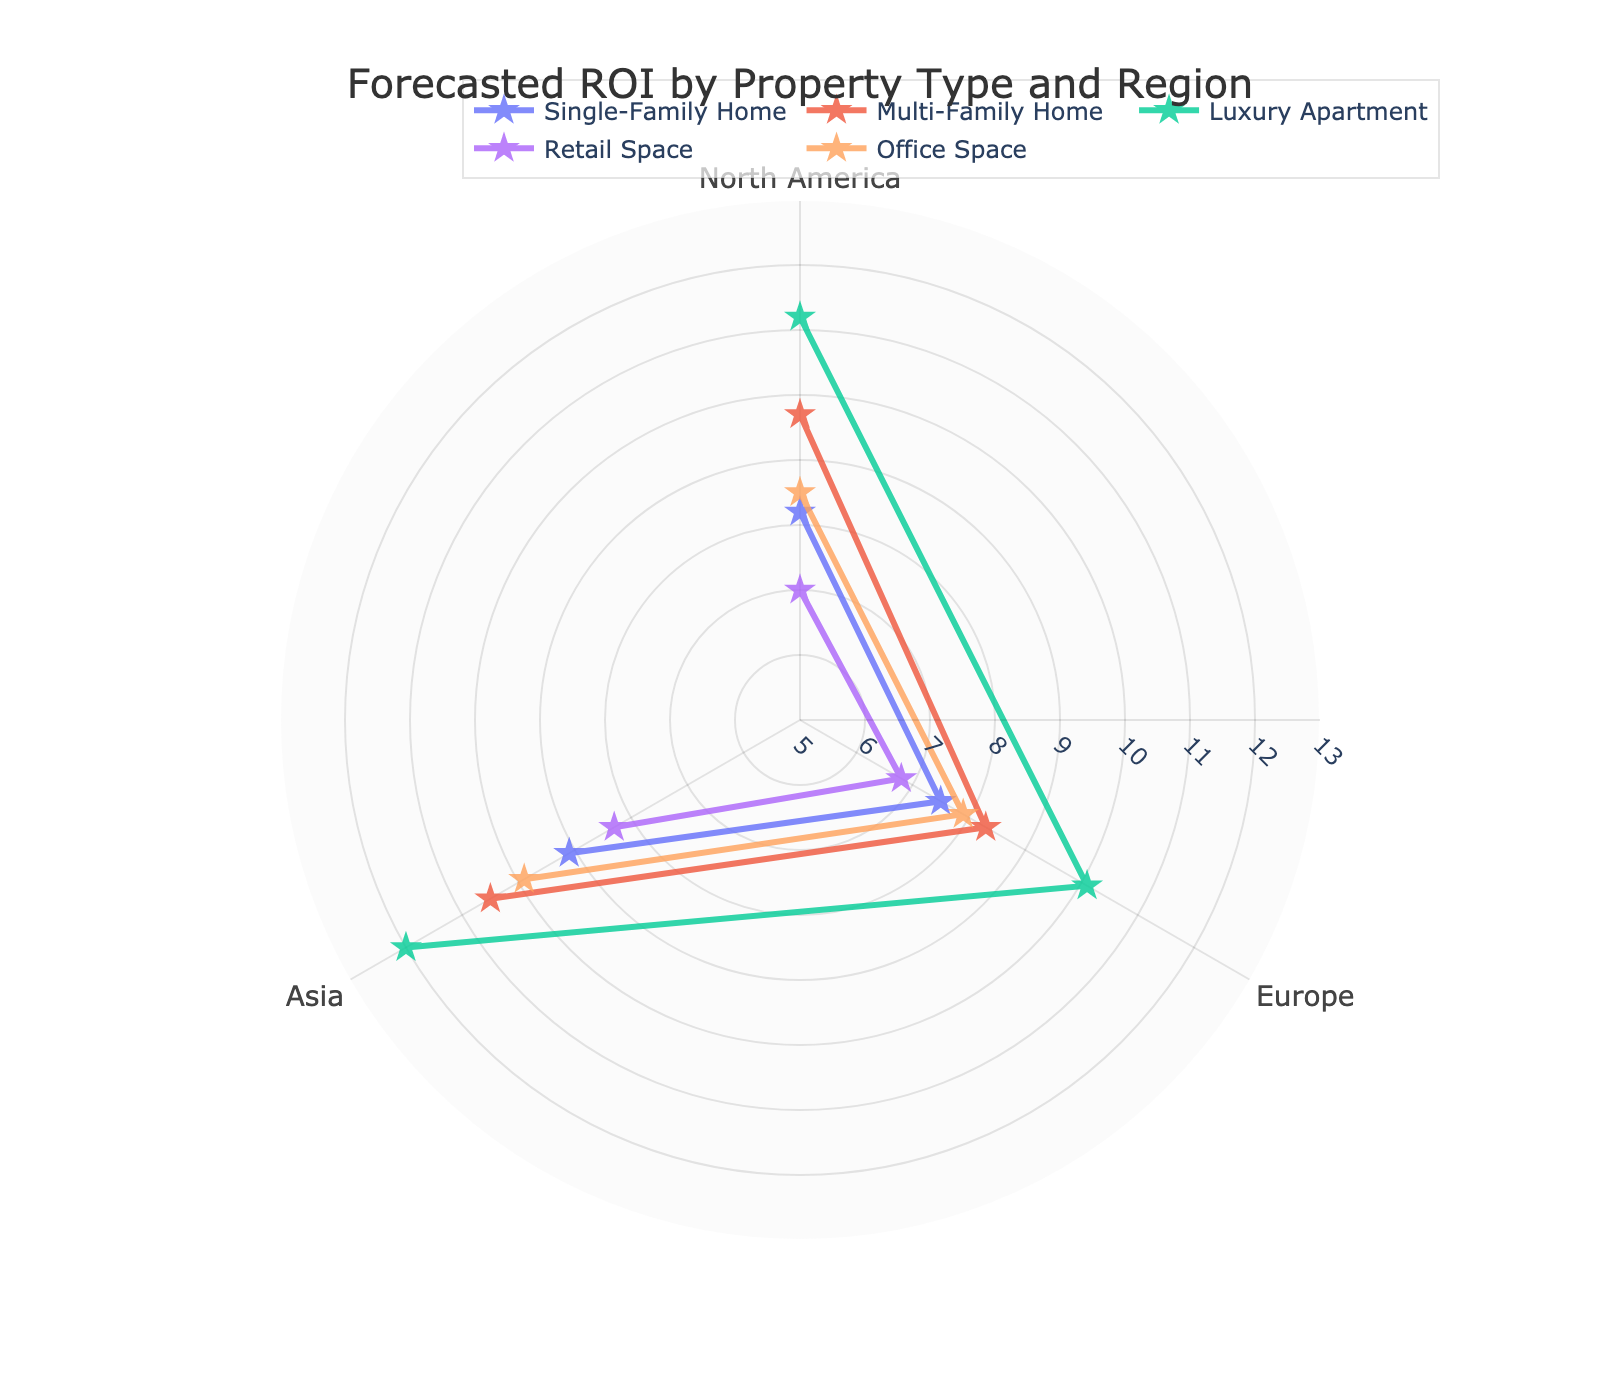What is the title of the polar chart? The title of the polar chart is prominently displayed at the top of the figure. By reading the title, you can easily identify it.
Answer: Forecasted ROI by Property Type and Region Which property type has the highest ROI in Asia? Looking at the markers for Asia, the highest ROI appears to be for Luxury Apartment at 12.0.
Answer: Luxury Apartment What is the lowest ROI in Europe, and which property type does it belong to? By examining the markers for Europe, the lowest ROI is 6.8, which belongs to Retail Space.
Answer: Retail Space How many property types are represented in the chart? There are four distinct property types mentioned: Single-Family Home, Multi-Family Home, Luxury Apartment, and Retail Space.
Answer: Four What is the difference in ROI between Single-Family Homes in North America and Asia? The ROI for Single-Family Homes in North America is 8.2 and in Asia is 9.1. Subtracting these values gives 9.1 - 8.2 = 0.9.
Answer: 0.9 Which region has the most consistent ROI across different property types? Compare the variation in ROIs across property types within each region. North America has a smaller spread in ROIs ranging roughly from 7.0 to 11.2, while other regions have larger variations.
Answer: North America Which property type shows the greatest variability in ROI across all regions? By comparing the variation in ROIs for each property type across the three regions, Luxury Apartment shows the greatest range from 10.1 in Europe to 12.0 in Asia.
Answer: Luxury Apartment What is the average ROI for all property types in North America? Summing the ROIs in North America (8.2 + 9.7 + 11.2 + 7.0 + 8.5) and dividing by the number of property types (5) gives (8.2 + 9.7 + 11.2 + 7.0 + 8.5) / 5 = 8.92.
Answer: 8.92 Which property type has the lowest ROI overall and in which region? By examining all markers, the lowest ROI overall appears to be Retail Space in Europe with a value of 6.8.
Answer: Retail Space, Europe 